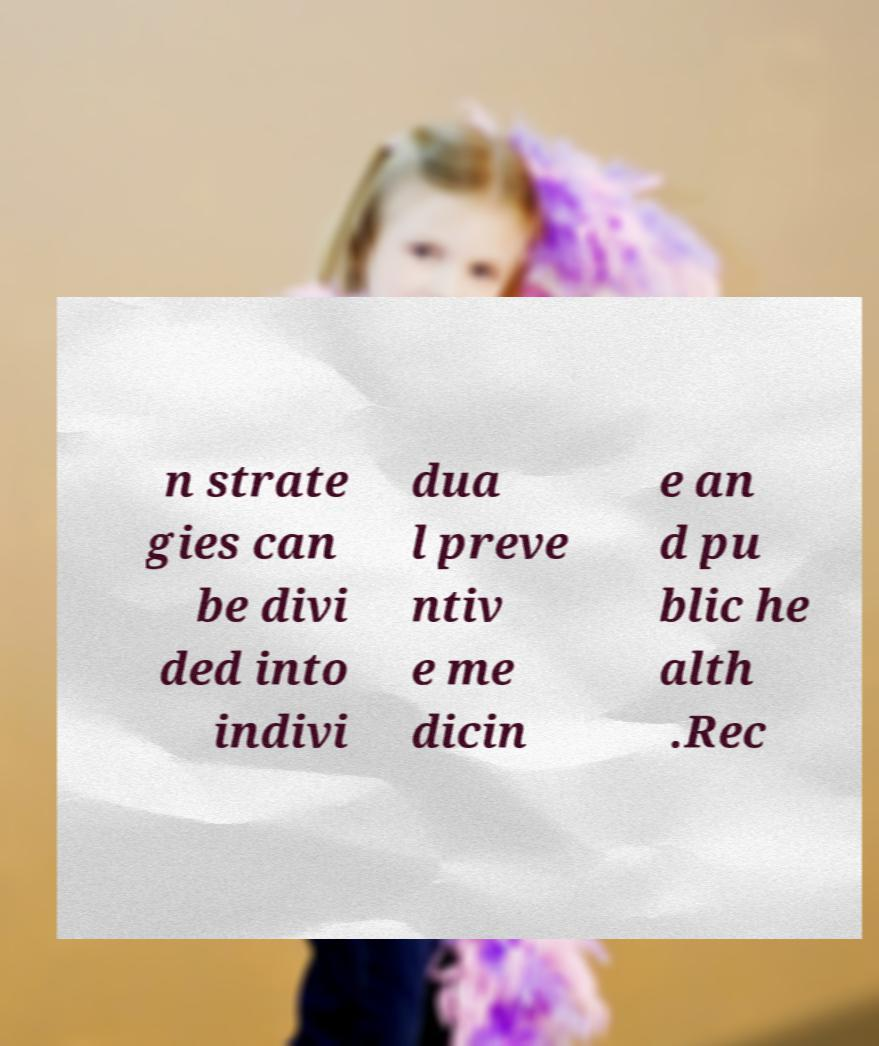There's text embedded in this image that I need extracted. Can you transcribe it verbatim? n strate gies can be divi ded into indivi dua l preve ntiv e me dicin e an d pu blic he alth .Rec 